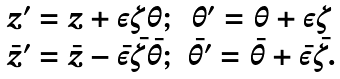Convert formula to latex. <formula><loc_0><loc_0><loc_500><loc_500>\begin{array} { c c } z ^ { \prime } = z + \varepsilon \zeta \theta ; & \theta ^ { \prime } = \theta + \varepsilon \zeta \\ \bar { z } ^ { \prime } = \bar { z } - \bar { \varepsilon } \bar { \zeta } \bar { \theta } ; & \bar { \theta } ^ { \prime } = \bar { \theta } + \bar { \varepsilon } \bar { \zeta } . \end{array}</formula> 